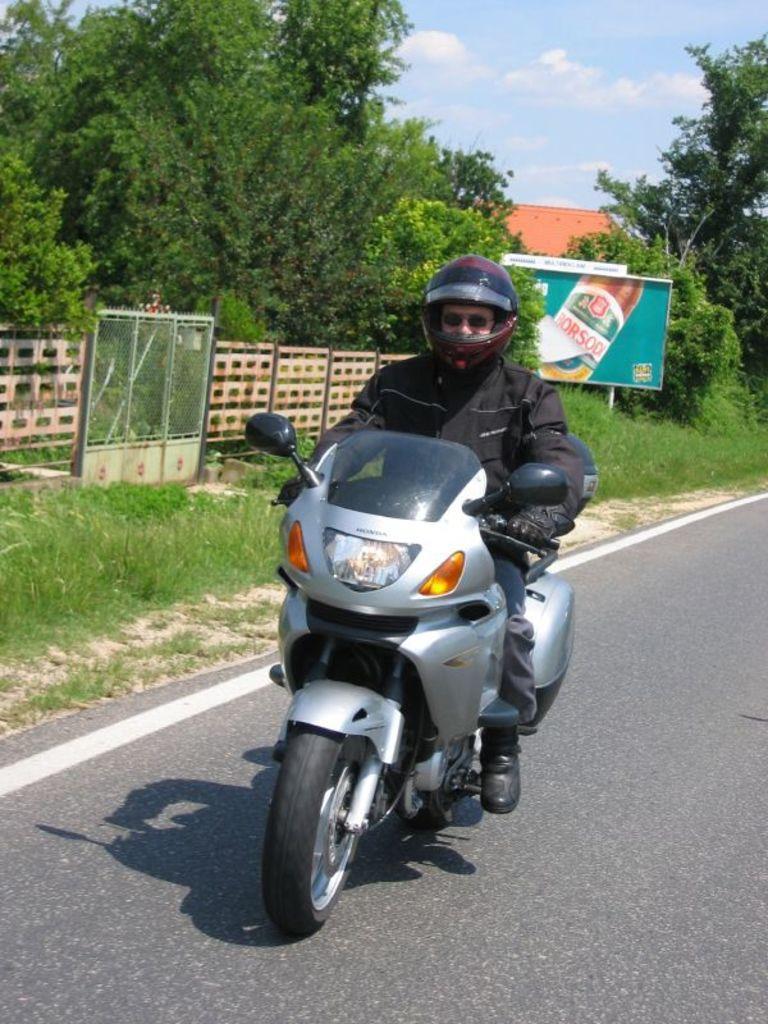Could you give a brief overview of what you see in this image? In this picture we can see a man is riding motorcycle on the road, he wore a helmet, in the background we can see a hoarding, few trees and a house. 